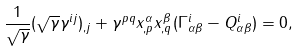Convert formula to latex. <formula><loc_0><loc_0><loc_500><loc_500>\frac { 1 } { \sqrt { \gamma } } ( \sqrt { \gamma } \gamma ^ { i j } ) _ { , j } + \gamma ^ { p q } x _ { , p } ^ { \alpha } x _ { , q } ^ { \beta } ( \Gamma _ { \alpha \beta } ^ { i } - Q _ { \alpha \beta } ^ { i } ) = 0 ,</formula> 